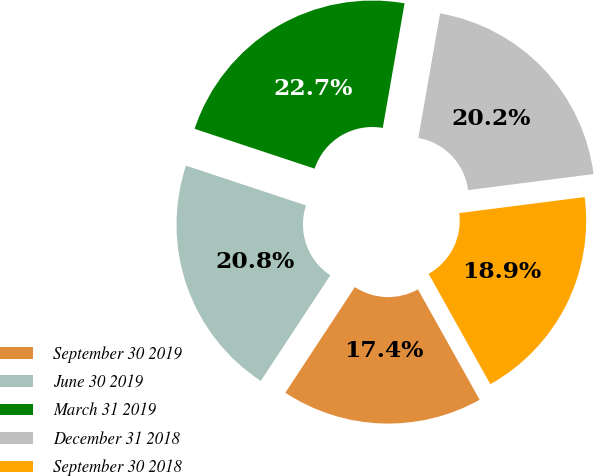Convert chart. <chart><loc_0><loc_0><loc_500><loc_500><pie_chart><fcel>September 30 2019<fcel>June 30 2019<fcel>March 31 2019<fcel>December 31 2018<fcel>September 30 2018<nl><fcel>17.38%<fcel>20.83%<fcel>22.66%<fcel>20.22%<fcel>18.91%<nl></chart> 